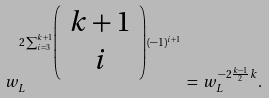Convert formula to latex. <formula><loc_0><loc_0><loc_500><loc_500>w _ { L } ^ { 2 \sum _ { i = 3 } ^ { k + 1 } \left ( \begin{array} { c } k + 1 \\ i \end{array} \right ) ( - 1 ) ^ { i + 1 } } \, = \, w _ { L } ^ { - 2 \frac { k - 1 } { 2 } k } .</formula> 